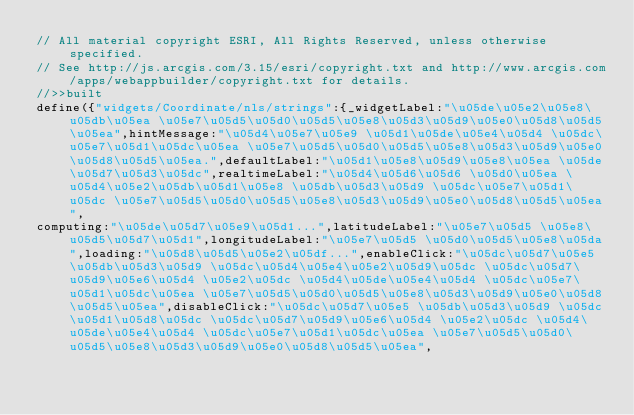Convert code to text. <code><loc_0><loc_0><loc_500><loc_500><_JavaScript_>// All material copyright ESRI, All Rights Reserved, unless otherwise specified.
// See http://js.arcgis.com/3.15/esri/copyright.txt and http://www.arcgis.com/apps/webappbuilder/copyright.txt for details.
//>>built
define({"widgets/Coordinate/nls/strings":{_widgetLabel:"\u05de\u05e2\u05e8\u05db\u05ea \u05e7\u05d5\u05d0\u05d5\u05e8\u05d3\u05d9\u05e0\u05d8\u05d5\u05ea",hintMessage:"\u05d4\u05e7\u05e9 \u05d1\u05de\u05e4\u05d4 \u05dc\u05e7\u05d1\u05dc\u05ea \u05e7\u05d5\u05d0\u05d5\u05e8\u05d3\u05d9\u05e0\u05d8\u05d5\u05ea.",defaultLabel:"\u05d1\u05e8\u05d9\u05e8\u05ea \u05de\u05d7\u05d3\u05dc",realtimeLabel:"\u05d4\u05d6\u05d6 \u05d0\u05ea \u05d4\u05e2\u05db\u05d1\u05e8 \u05db\u05d3\u05d9 \u05dc\u05e7\u05d1\u05dc \u05e7\u05d5\u05d0\u05d5\u05e8\u05d3\u05d9\u05e0\u05d8\u05d5\u05ea",
computing:"\u05de\u05d7\u05e9\u05d1...",latitudeLabel:"\u05e7\u05d5 \u05e8\u05d5\u05d7\u05d1",longitudeLabel:"\u05e7\u05d5 \u05d0\u05d5\u05e8\u05da",loading:"\u05d8\u05d5\u05e2\u05df...",enableClick:"\u05dc\u05d7\u05e5 \u05db\u05d3\u05d9 \u05dc\u05d4\u05e4\u05e2\u05d9\u05dc \u05dc\u05d7\u05d9\u05e6\u05d4 \u05e2\u05dc \u05d4\u05de\u05e4\u05d4 \u05dc\u05e7\u05d1\u05dc\u05ea \u05e7\u05d5\u05d0\u05d5\u05e8\u05d3\u05d9\u05e0\u05d8\u05d5\u05ea",disableClick:"\u05dc\u05d7\u05e5 \u05db\u05d3\u05d9 \u05dc\u05d1\u05d8\u05dc \u05dc\u05d7\u05d9\u05e6\u05d4 \u05e2\u05dc \u05d4\u05de\u05e4\u05d4 \u05dc\u05e7\u05d1\u05dc\u05ea \u05e7\u05d5\u05d0\u05d5\u05e8\u05d3\u05d9\u05e0\u05d8\u05d5\u05ea",</code> 